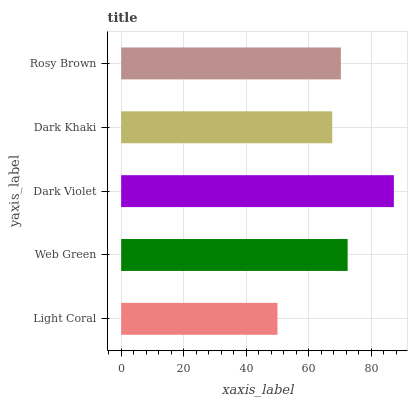Is Light Coral the minimum?
Answer yes or no. Yes. Is Dark Violet the maximum?
Answer yes or no. Yes. Is Web Green the minimum?
Answer yes or no. No. Is Web Green the maximum?
Answer yes or no. No. Is Web Green greater than Light Coral?
Answer yes or no. Yes. Is Light Coral less than Web Green?
Answer yes or no. Yes. Is Light Coral greater than Web Green?
Answer yes or no. No. Is Web Green less than Light Coral?
Answer yes or no. No. Is Rosy Brown the high median?
Answer yes or no. Yes. Is Rosy Brown the low median?
Answer yes or no. Yes. Is Dark Khaki the high median?
Answer yes or no. No. Is Dark Khaki the low median?
Answer yes or no. No. 